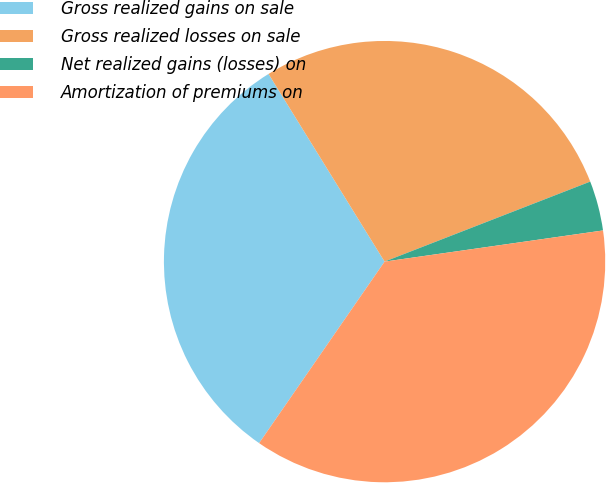<chart> <loc_0><loc_0><loc_500><loc_500><pie_chart><fcel>Gross realized gains on sale<fcel>Gross realized losses on sale<fcel>Net realized gains (losses) on<fcel>Amortization of premiums on<nl><fcel>31.56%<fcel>27.91%<fcel>3.65%<fcel>36.88%<nl></chart> 